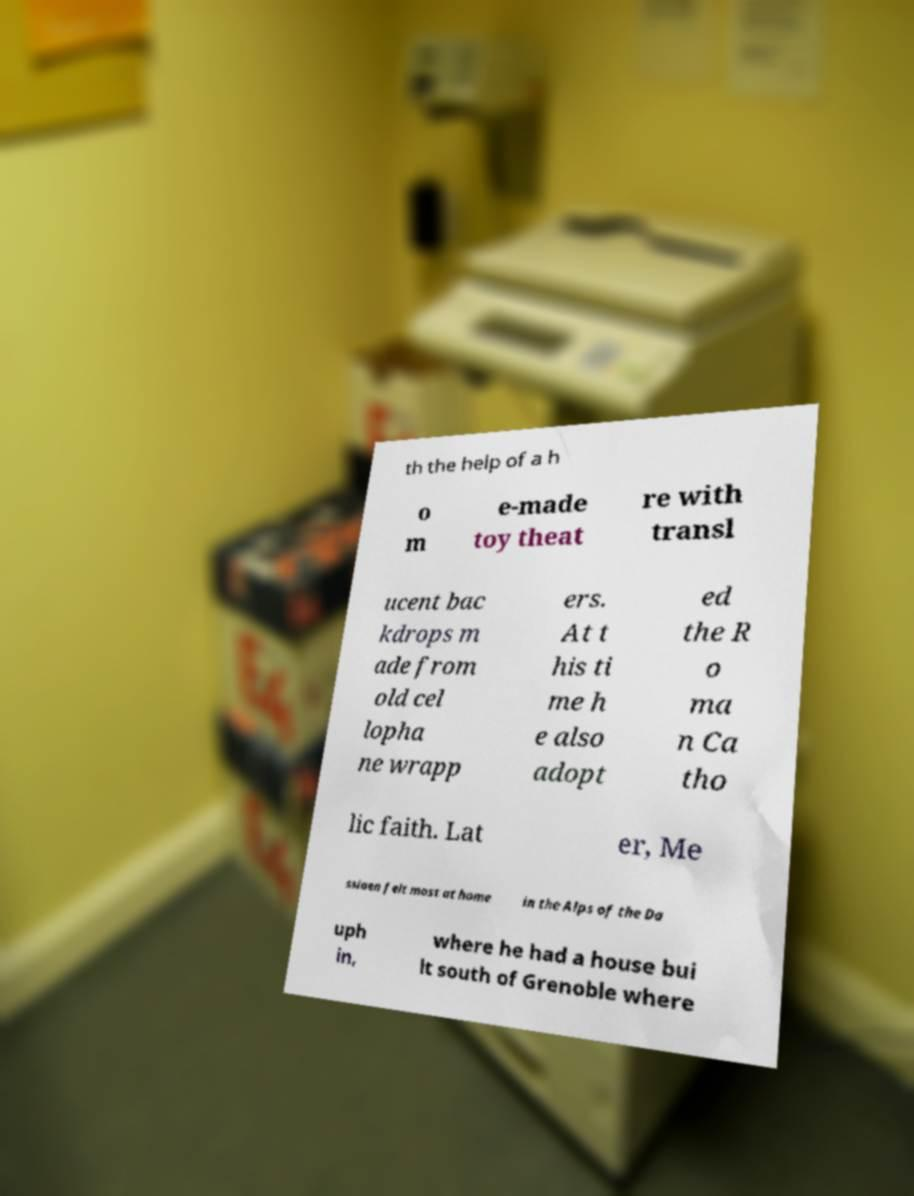For documentation purposes, I need the text within this image transcribed. Could you provide that? th the help of a h o m e-made toy theat re with transl ucent bac kdrops m ade from old cel lopha ne wrapp ers. At t his ti me h e also adopt ed the R o ma n Ca tho lic faith. Lat er, Me ssiaen felt most at home in the Alps of the Da uph in, where he had a house bui lt south of Grenoble where 